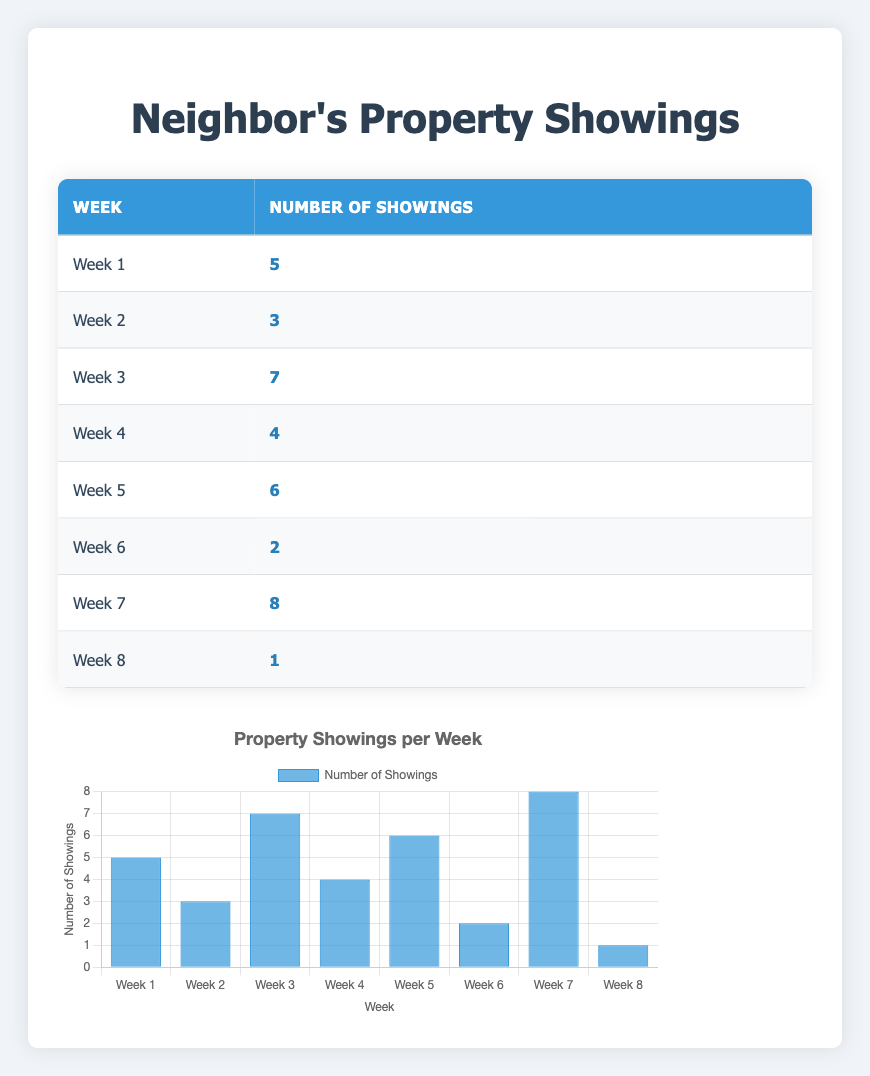What was the highest number of showings recorded in a week? From the table, we can look through the number of showings for each week. The maximum value among the showings is 8, which occurred in Week 7.
Answer: 8 Which week had the least number of showings? By reviewing the table, we can see that Week 8 had only 1 showing, which is the lowest compared to other weeks.
Answer: Week 8 What is the average number of showings across the eight weeks? To find the average, we first sum all the showings: 5 + 3 + 7 + 4 + 6 + 2 + 8 + 1 = 36. Then, we divide by the number of weeks (8): 36/8 = 4.5.
Answer: 4.5 Is it true that the number of showings increased every week? Reviewing the showings per week in the table, it's evident that the showings did not increase every week; there were fluctuations, such as the decrease from Week 7 to Week 8.
Answer: No How many showings were there from Weeks 3 to 5 combined? To find the total for Weeks 3, 4, and 5, we add the respective showings: Week 3 (7) + Week 4 (4) + Week 5 (6) = 17.
Answer: 17 Was Week 6 the week with the second lowest showings? In the table, Week 6 has 2 showings, but Week 8 has the least with 1 showing, making Week 6 the second lowest. Hence, this is true.
Answer: Yes What was the total number of showings over the entire eight-week period? By adding all the showings from the table: 5 + 3 + 7 + 4 + 6 + 2 + 8 + 1 = 36. This gives the total for the entire period.
Answer: 36 Which week had more showings, Week 1 or Week 5? Looking at the table, Week 1 had 5 showings while Week 5 had 6. Hence, Week 5 had more showings than Week 1.
Answer: Week 5 Which weeks had showings greater than 5? We examine each week's showings: Week 3 (7), Week 5 (6), and Week 7 (8) are all greater than 5. Thus, these three weeks had more showings.
Answer: Week 3, Week 5, Week 7 